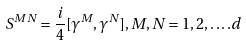<formula> <loc_0><loc_0><loc_500><loc_500>S ^ { M N } = \frac { i } { 4 } [ \gamma ^ { M } , \gamma ^ { N } ] , M , N = 1 , 2 , \dots . d</formula> 